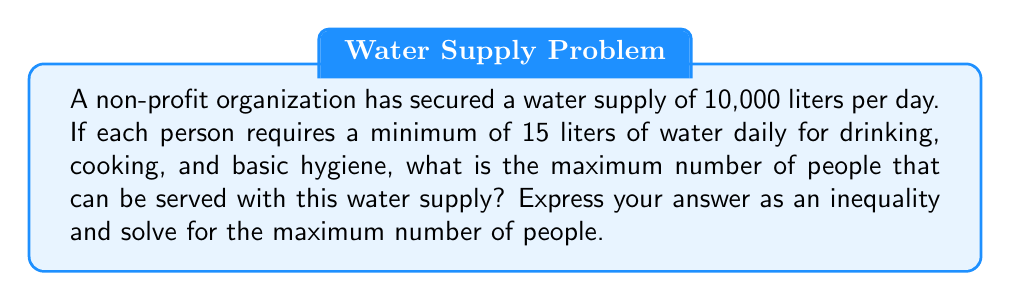Teach me how to tackle this problem. Let's approach this step-by-step:

1) Let $x$ be the number of people served.

2) Each person requires at least 15 liters of water per day.
   So, the total water required for $x$ people is $15x$ liters.

3) We have 10,000 liters available per day.

4) To serve the maximum number of people, we can set up the inequality:

   $15x \leq 10000$

5) To solve for $x$, divide both sides by 15:

   $x \leq \frac{10000}{15}$

6) Simplify:
   
   $x \leq 666.\overline{6}$

7) Since we're dealing with whole people, we need to round down to the nearest integer.

Therefore, the maximum number of people that can be served is 666.
Answer: 666 people 